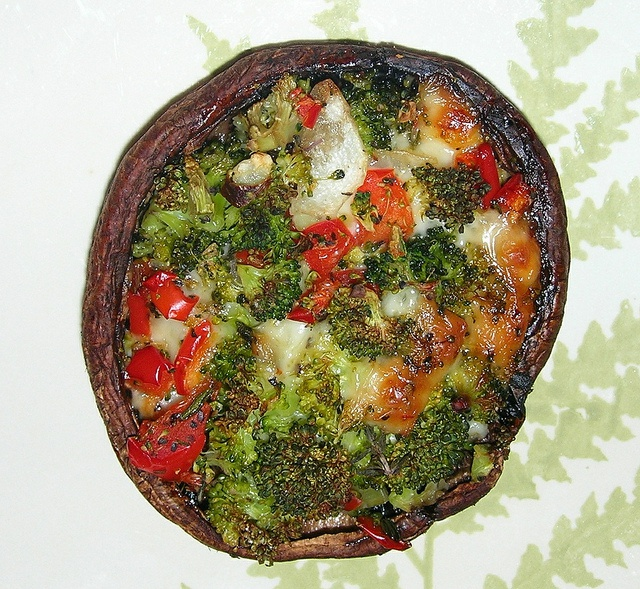Describe the objects in this image and their specific colors. I can see pizza in white, black, olive, and maroon tones, broccoli in white, darkgreen, black, and olive tones, broccoli in white, black, darkgreen, olive, and maroon tones, broccoli in white, black, olive, and darkgreen tones, and broccoli in white, olive, black, and maroon tones in this image. 